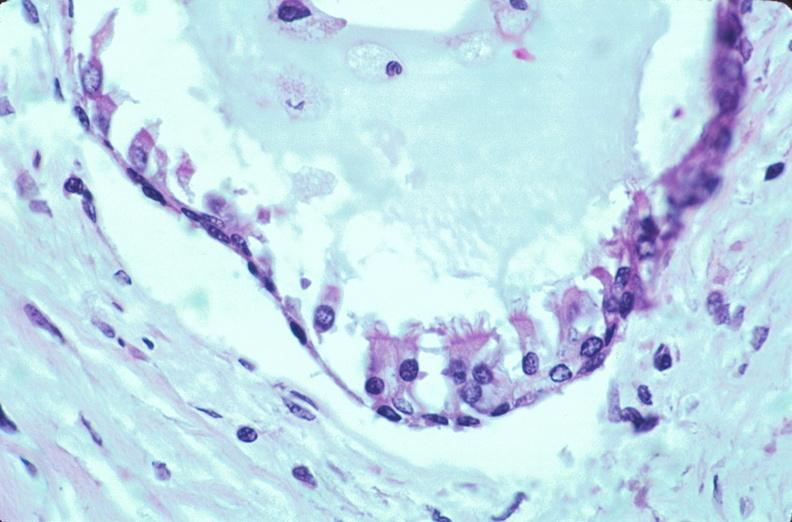how many yo does this image show pharyngeal pouch remnant, incidental finding in man?
Answer the question using a single word or phrase. 32 